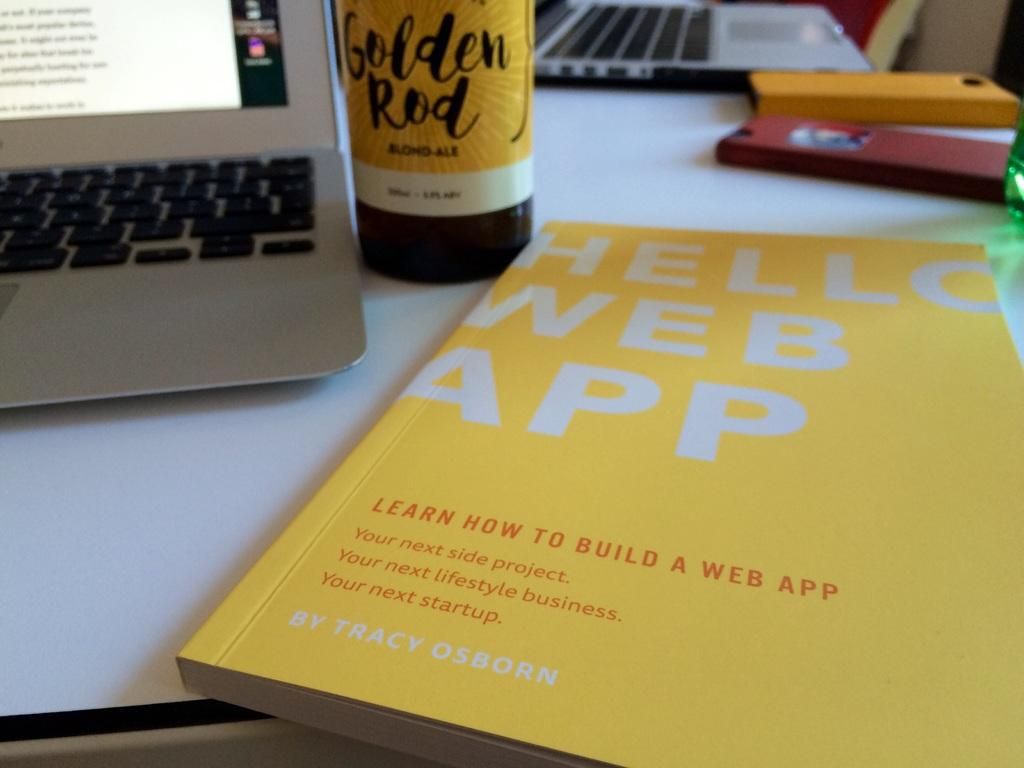<image>
Summarize the visual content of the image. the word web that is on a yellow book 